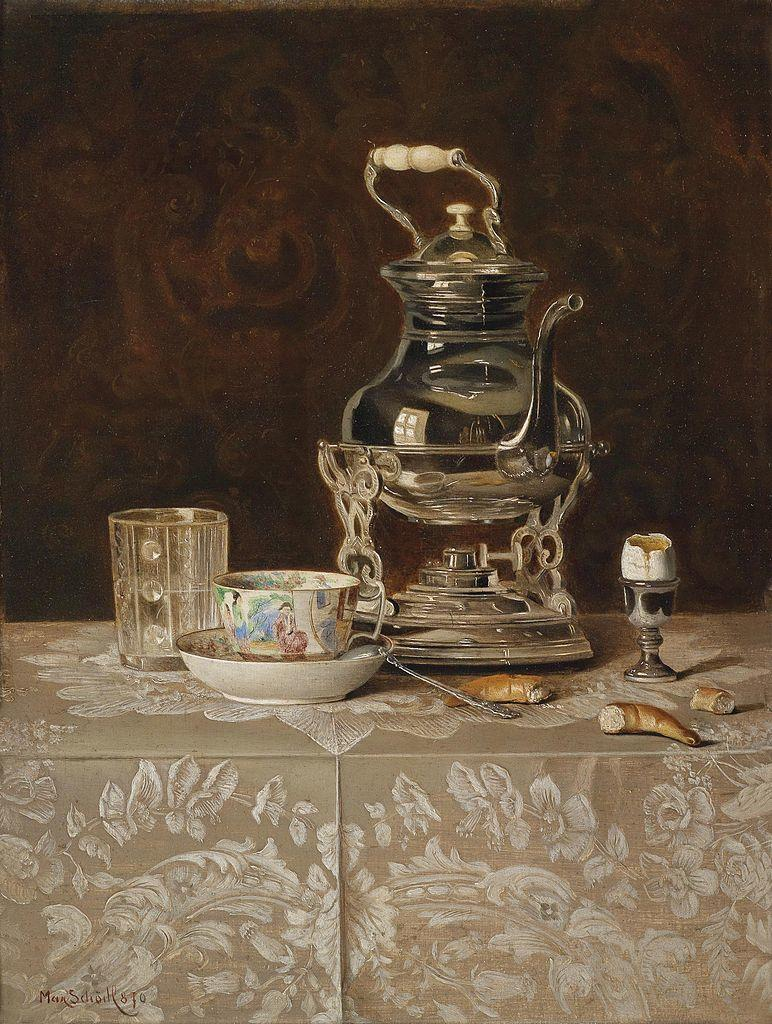What piece of furniture is present in the image? There is a table in the image. What is placed on the table? There is a kettle, a glass, and a bowl on the table. Is there anything unusual on the bowl? Yes, there is a cup on the bowl. Are there any other items near the kettle? Yes, there are additional items near the kettle. What year is depicted in the image? The image does not depict a specific year. Is there a door visible in the image? There is no door present in the image. 